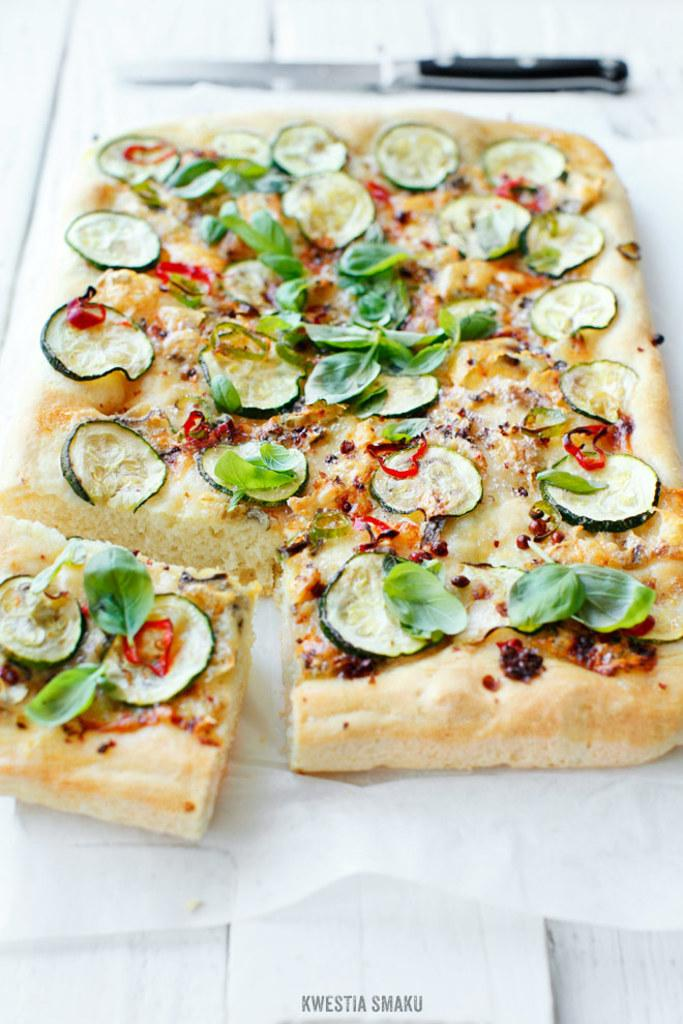What is present on the plate in the image? There are food items on the plate in the image. Can you describe the food items on the plate? Unfortunately, the specific food items cannot be determined from the provided facts. How many dolls are present in the cemetery in the image? There is no mention of dolls or a cemetery in the provided facts, so this question cannot be answered. 